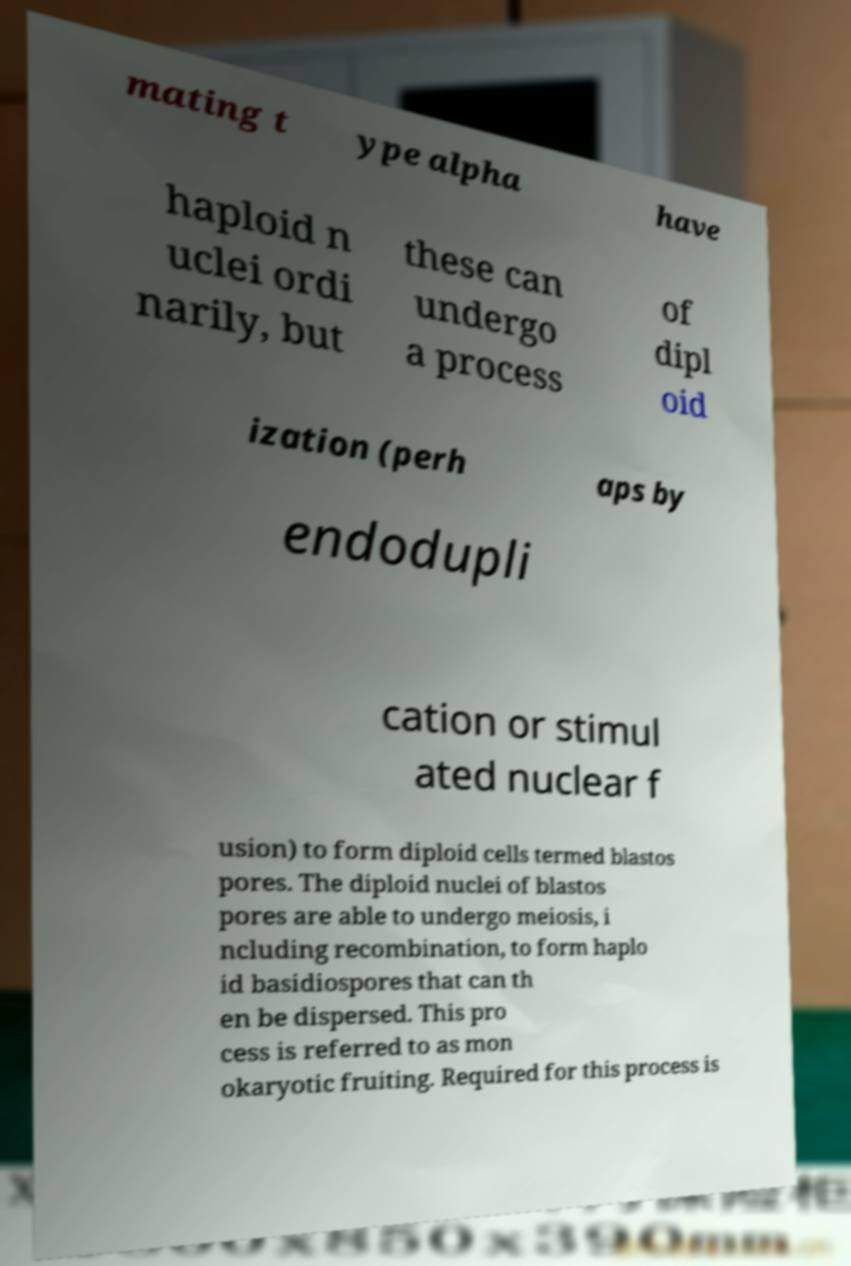Please read and relay the text visible in this image. What does it say? mating t ype alpha have haploid n uclei ordi narily, but these can undergo a process of dipl oid ization (perh aps by endodupli cation or stimul ated nuclear f usion) to form diploid cells termed blastos pores. The diploid nuclei of blastos pores are able to undergo meiosis, i ncluding recombination, to form haplo id basidiospores that can th en be dispersed. This pro cess is referred to as mon okaryotic fruiting. Required for this process is 